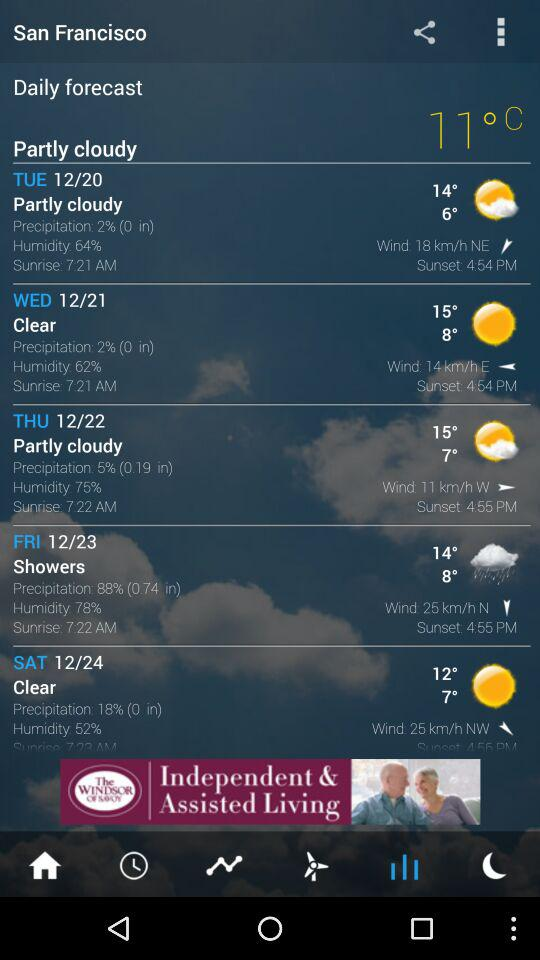What is the sunrise time on Wednesday? The sunrise time is 7:21 AM. 